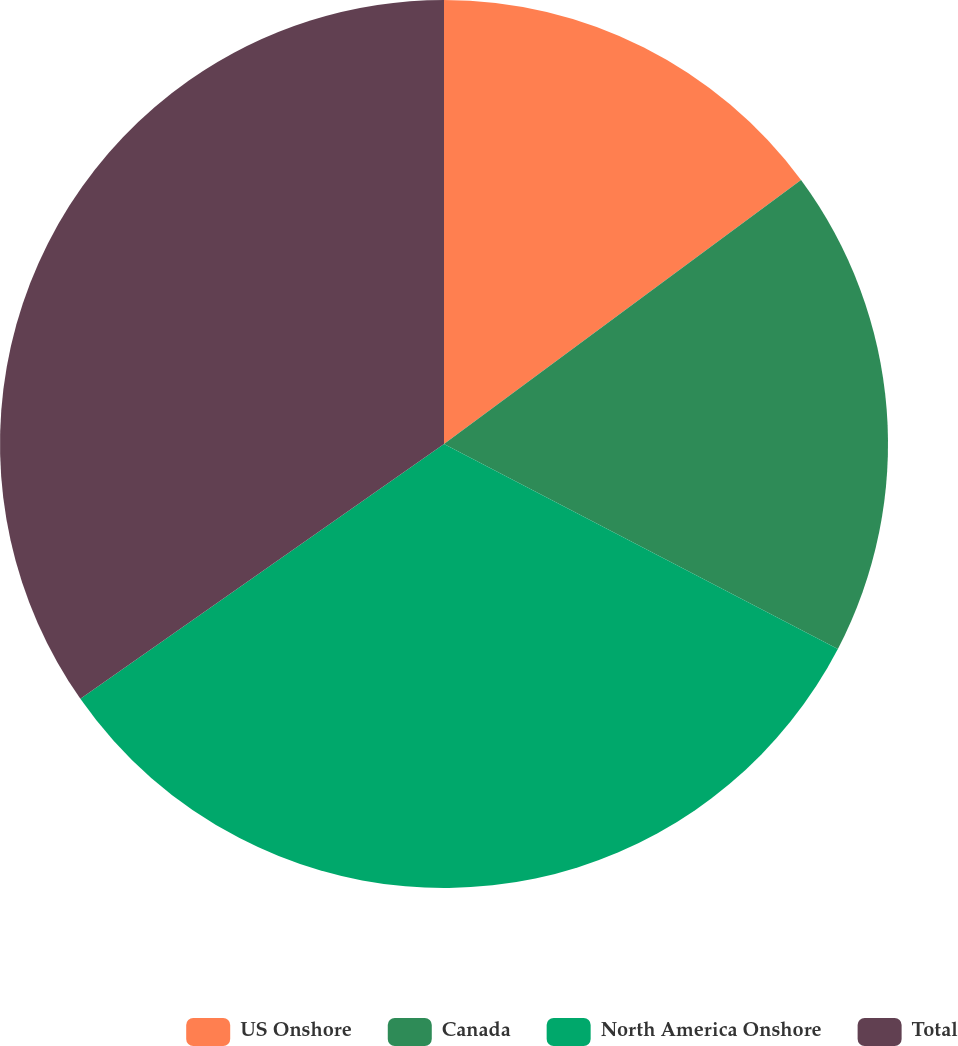Convert chart. <chart><loc_0><loc_0><loc_500><loc_500><pie_chart><fcel>US Onshore<fcel>Canada<fcel>North America Onshore<fcel>Total<nl><fcel>14.87%<fcel>17.77%<fcel>32.64%<fcel>34.73%<nl></chart> 